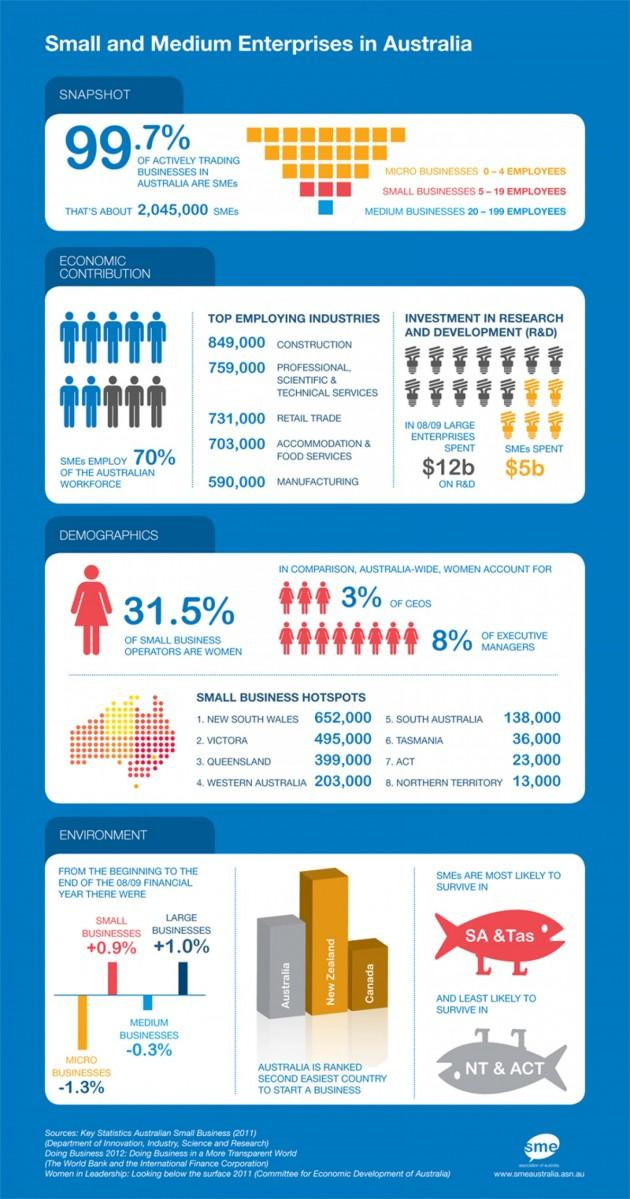Identify some key points in this picture. SMEs spent approximately $5 billion on research and development in the year 2020. SMEs spent significantly less than large enterprises on R&D, with a difference of $7b. 